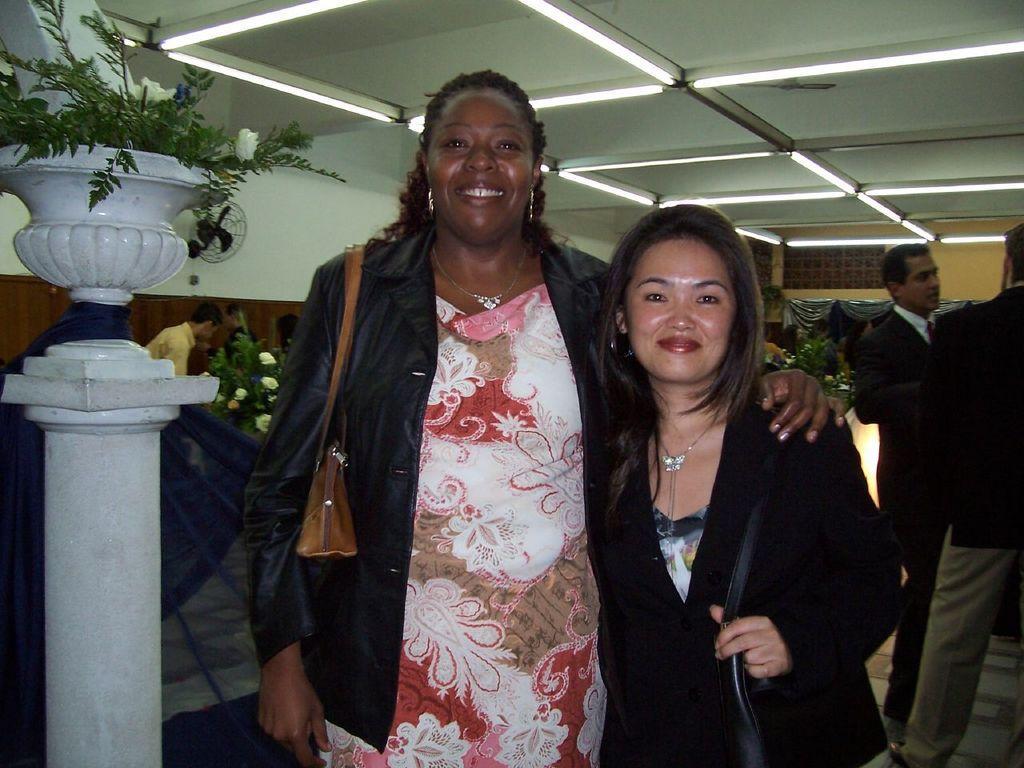How would you summarize this image in a sentence or two? Here people are standing, there is a plant, where there are lights to the roof. 